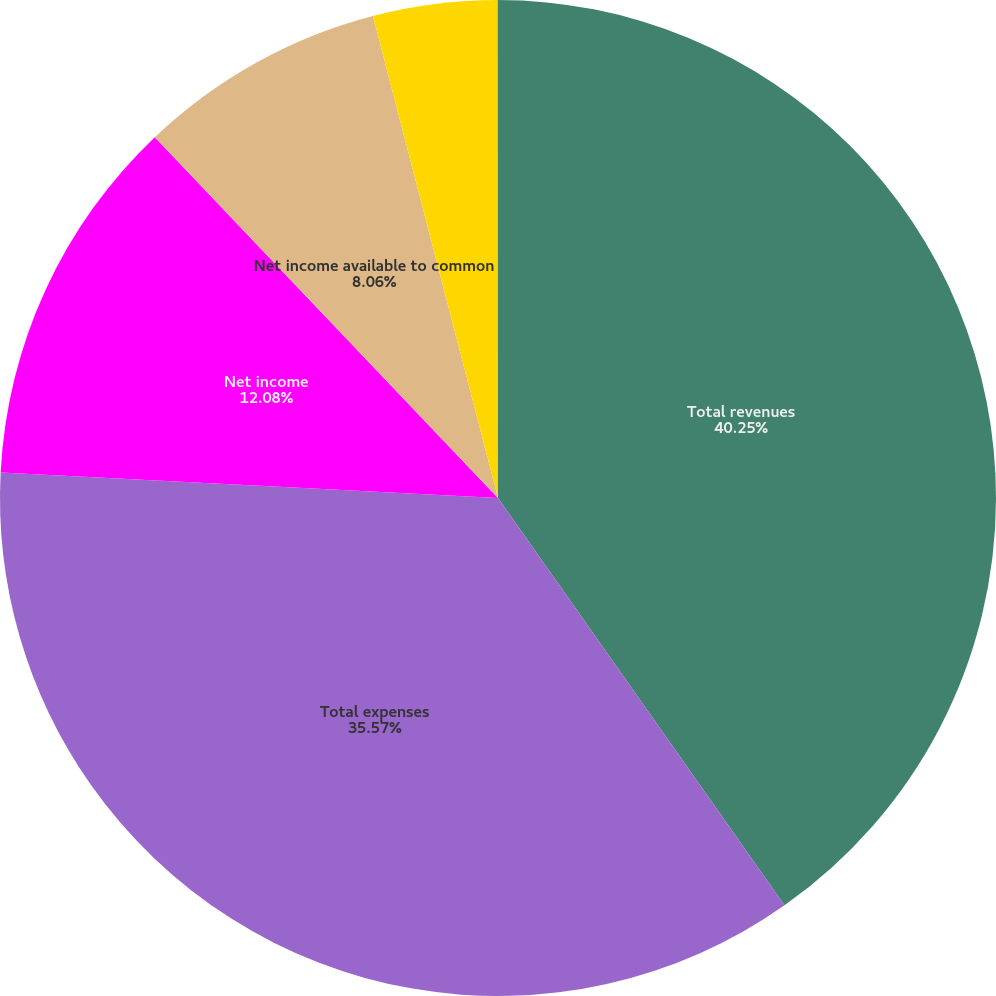Convert chart. <chart><loc_0><loc_0><loc_500><loc_500><pie_chart><fcel>Total revenues<fcel>Total expenses<fcel>Net income<fcel>Net income available to common<fcel>Basic earnings per common<fcel>Diluted earnings per common<nl><fcel>40.24%<fcel>35.57%<fcel>12.08%<fcel>8.06%<fcel>4.03%<fcel>0.01%<nl></chart> 